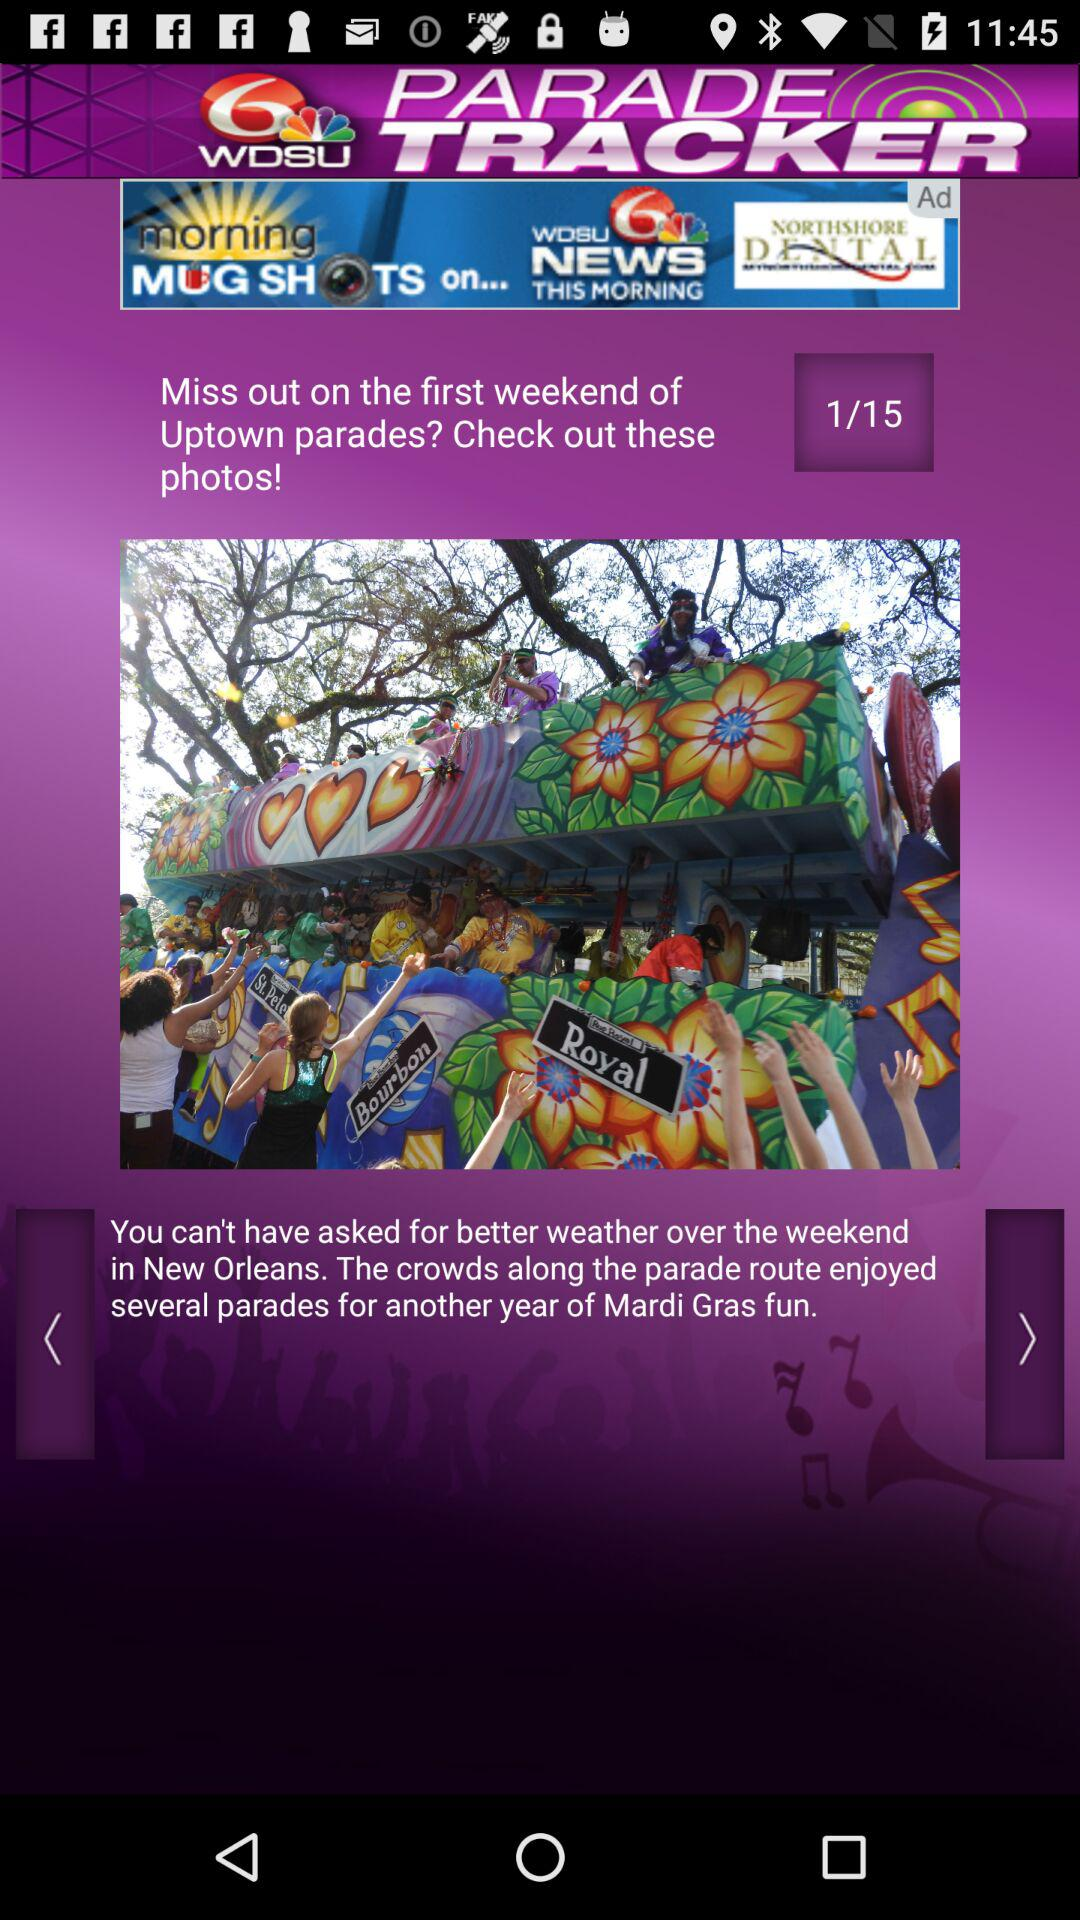On which page is the person currently? The person is currently on page 1. 